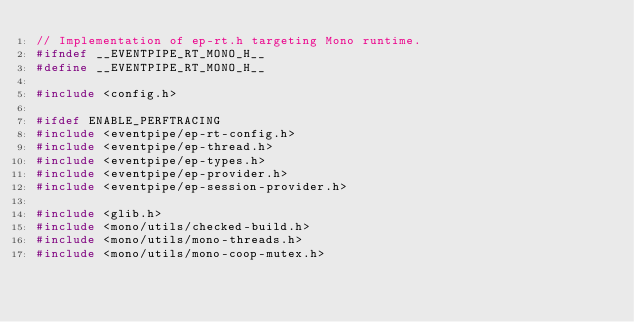Convert code to text. <code><loc_0><loc_0><loc_500><loc_500><_C_>// Implementation of ep-rt.h targeting Mono runtime.
#ifndef __EVENTPIPE_RT_MONO_H__
#define __EVENTPIPE_RT_MONO_H__

#include <config.h>

#ifdef ENABLE_PERFTRACING
#include <eventpipe/ep-rt-config.h>
#include <eventpipe/ep-thread.h>
#include <eventpipe/ep-types.h>
#include <eventpipe/ep-provider.h>
#include <eventpipe/ep-session-provider.h>

#include <glib.h>
#include <mono/utils/checked-build.h>
#include <mono/utils/mono-threads.h>
#include <mono/utils/mono-coop-mutex.h></code> 